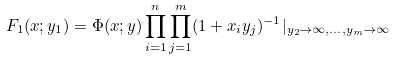Convert formula to latex. <formula><loc_0><loc_0><loc_500><loc_500>F _ { 1 } ( x ; y _ { 1 } ) = \Phi ( x ; y ) \prod _ { i = 1 } ^ { n } \prod _ { j = 1 } ^ { m } ( 1 + x _ { i } y _ { j } ) ^ { - 1 } | _ { y _ { 2 } \to \infty , \dots , y _ { m } \to \infty }</formula> 